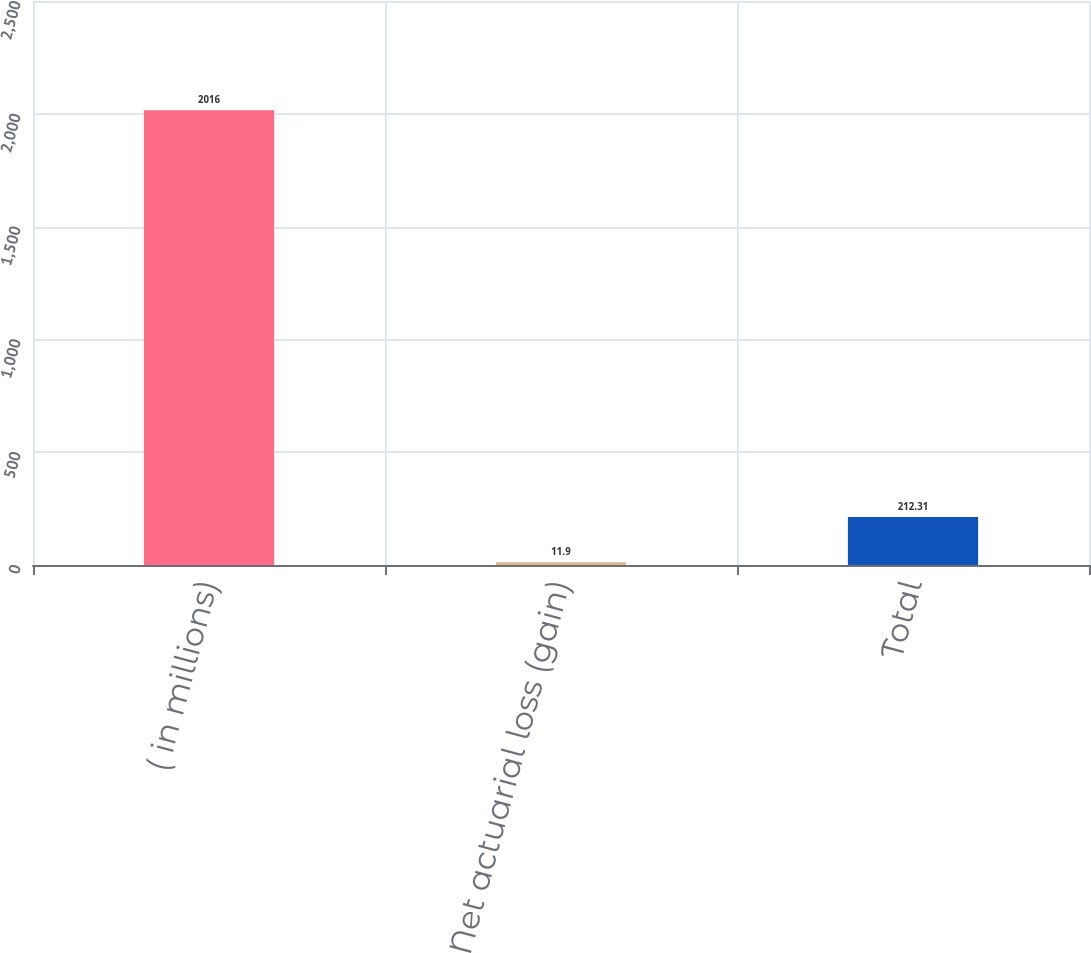Convert chart. <chart><loc_0><loc_0><loc_500><loc_500><bar_chart><fcel>( in millions)<fcel>Net actuarial loss (gain)<fcel>Total<nl><fcel>2016<fcel>11.9<fcel>212.31<nl></chart> 